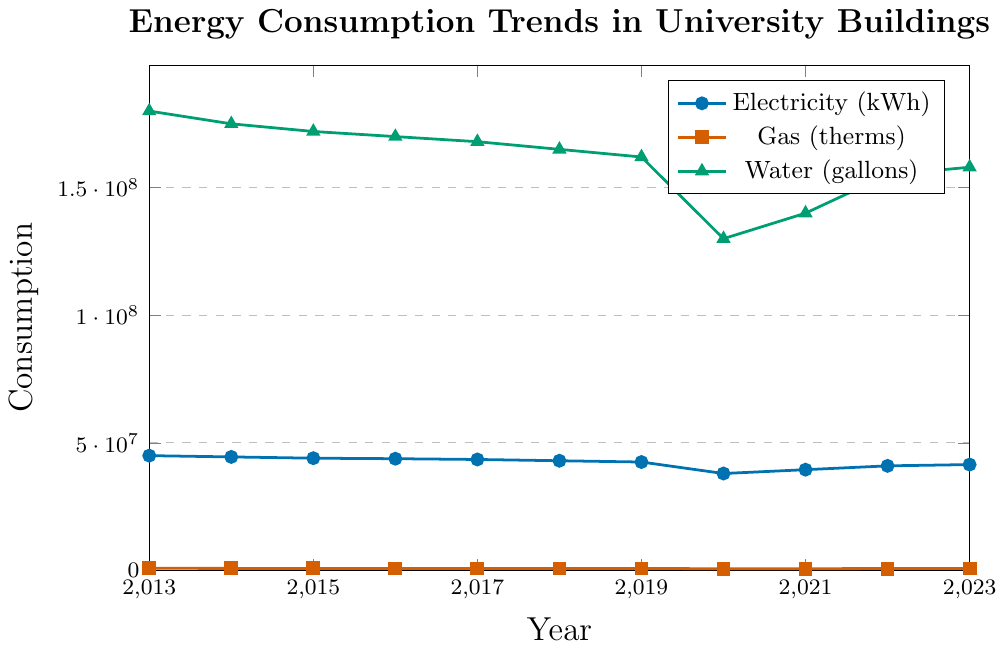What year saw the highest consumption of electricity? Look for the highest point on the electricity line (marked with circles). The highest point is in 2013.
Answer: 2013 How did water consumption change from 2019 to 2020? Look at the water line (marked with triangles) from 2019 to 2020; it drops from 162 million to 130 million gallons.
Answer: It decreased What is the average gas consumption from 2019 to 2023? Sum the gas consumption values from 2019 to 2023: 780,000 + 700,000 + 720,000 + 750,000 + 760,000 = 3,710,000. Then, divide by 5: 3,710,000 / 5 = 742,000.
Answer: 742,000 therms Which type of consumption saw the largest percentage decrease from 2013 to 2020? Calculate percentage decreases: 
- Electricity: (45,000,000 - 38,000,000) / 45,000,000 ≈ 15.56%
- Gas: (850,000 - 700,000) / 850,000 ≈ 17.65%
- Water: (180,000,000 - 130,000,000) / 180,000,000 ≈ 27.78%
Water saw the largest percentage decrease.
Answer: Water Describe the overall trend in electricity consumption over the decade. Observe the general direction of the electricity line (marked with circles). It generally decreases from 2013 to 2020 but slightly increases again towards 2023.
Answer: Decreasing In which year did electricity consumption see its largest drop compared to the previous year? Identify the year-to-year differences in the electricity line. The largest drop is from 2019 to 2020: 42,500,000 - 38,000,000 = 4,500,000 kWh.
Answer: 2020 What is the sum of all electricity consumption from 2013 to 2023? Sum all the electricity values: 45,000,000 + 44,500,000 + 44,000,000 + 43,800,000 + 43,500,000 + 43,000,000 + 42,500,000 + 38,000,000 + 39,500,000 + 41,000,000 + 41,500,000 = 426,300,000 kWh
Answer: 426,300,000 kWh How does the consumption of gas in 2023 compare to 2016? Compare the values for gas in 2023 and 2016: 760,000 (2023) and 810,000 (2016). Gas consumption decreased.
Answer: It decreased What color represents water consumption? Identify the color associated with the water line (triangles). The water line is green.
Answer: Green How much did water consumption increase from 2020 to 2023? Subtract the 2020 value from the 2023 value for water: 158,000,000 - 130,000,000 = 28,000,000 gallons.
Answer: 28,000,000 gallons 